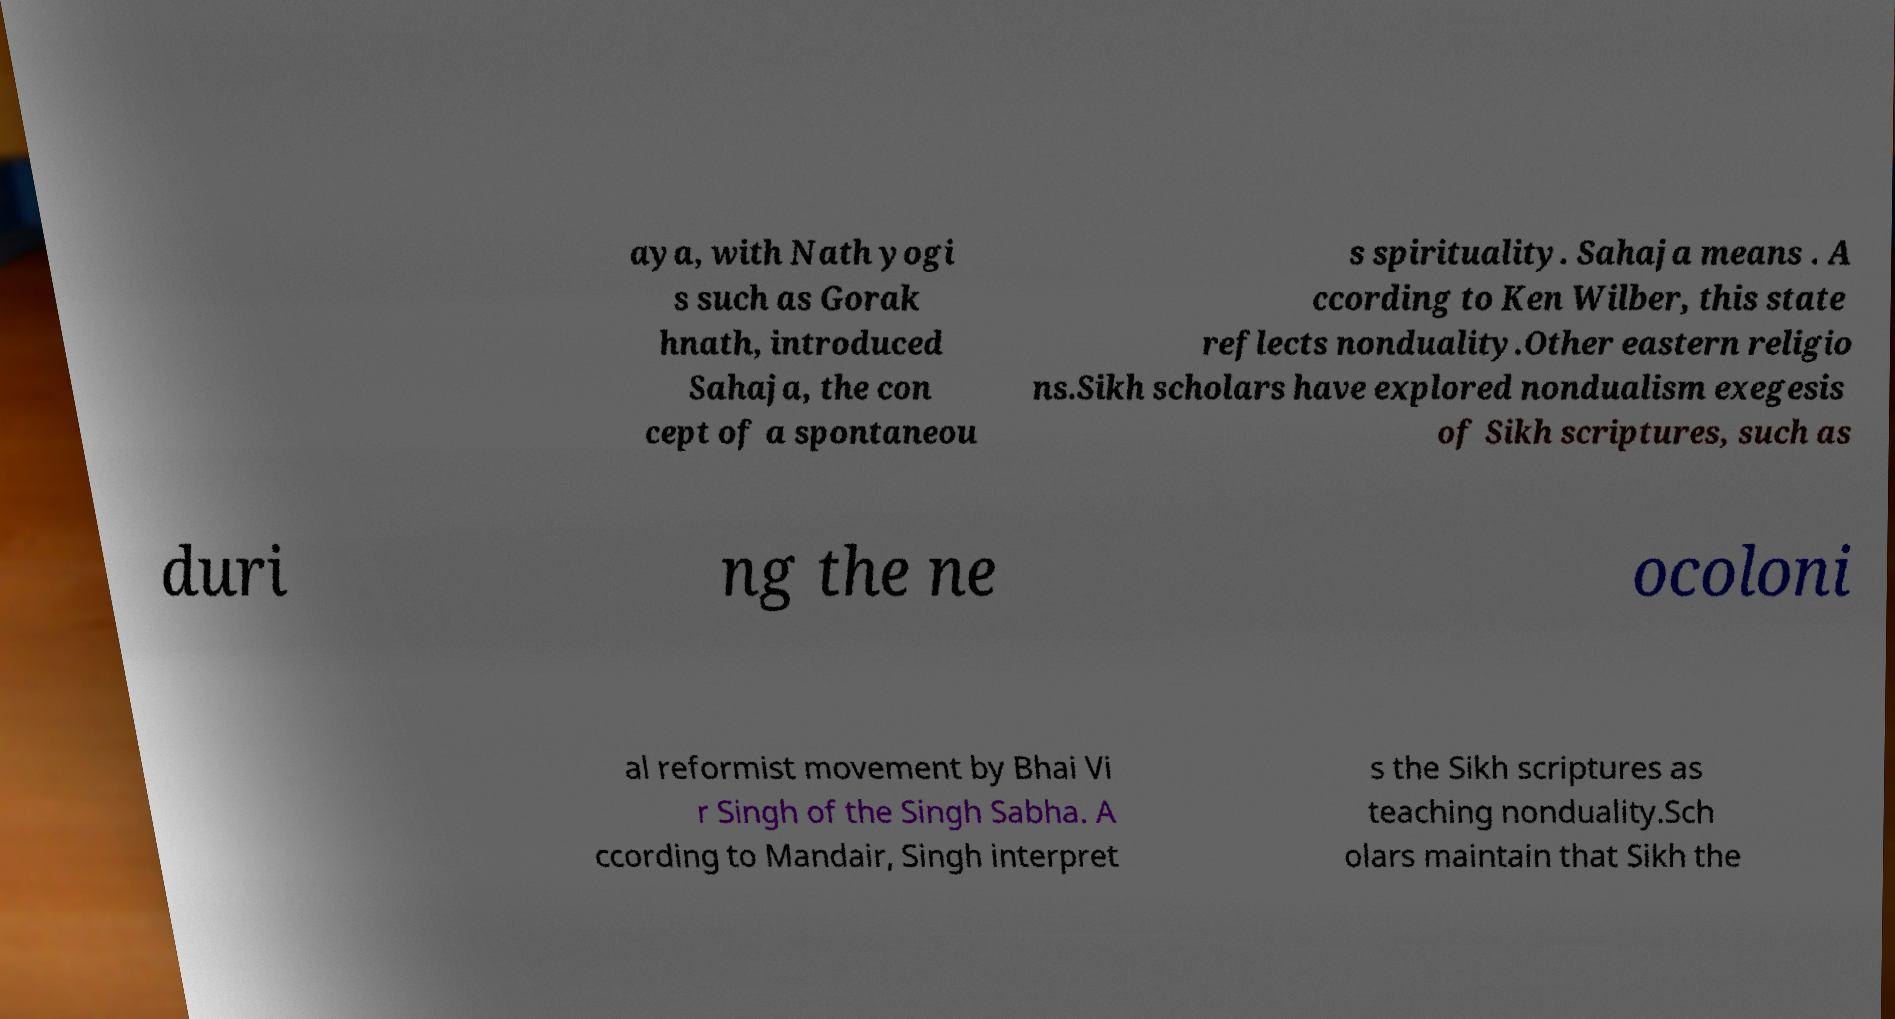Can you read and provide the text displayed in the image?This photo seems to have some interesting text. Can you extract and type it out for me? aya, with Nath yogi s such as Gorak hnath, introduced Sahaja, the con cept of a spontaneou s spirituality. Sahaja means . A ccording to Ken Wilber, this state reflects nonduality.Other eastern religio ns.Sikh scholars have explored nondualism exegesis of Sikh scriptures, such as duri ng the ne ocoloni al reformist movement by Bhai Vi r Singh of the Singh Sabha. A ccording to Mandair, Singh interpret s the Sikh scriptures as teaching nonduality.Sch olars maintain that Sikh the 